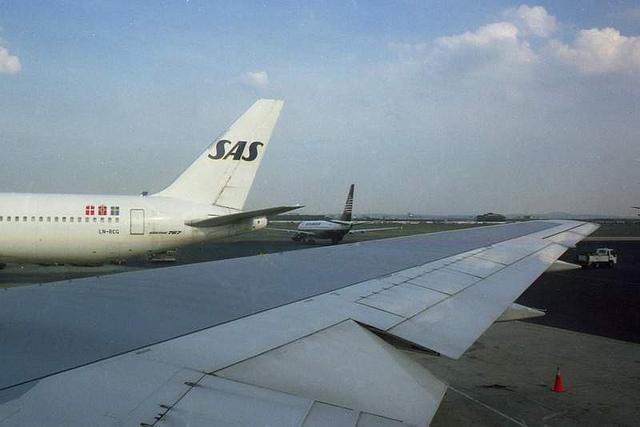How many cones are in the picture?
Keep it brief. 1. What number is in the bottom right corner of the picture?
Keep it brief. 0. What does the sign say?
Give a very brief answer. Sas. What airline is depicted here?
Quick response, please. Sas. Is the plane in flight?
Keep it brief. No. 